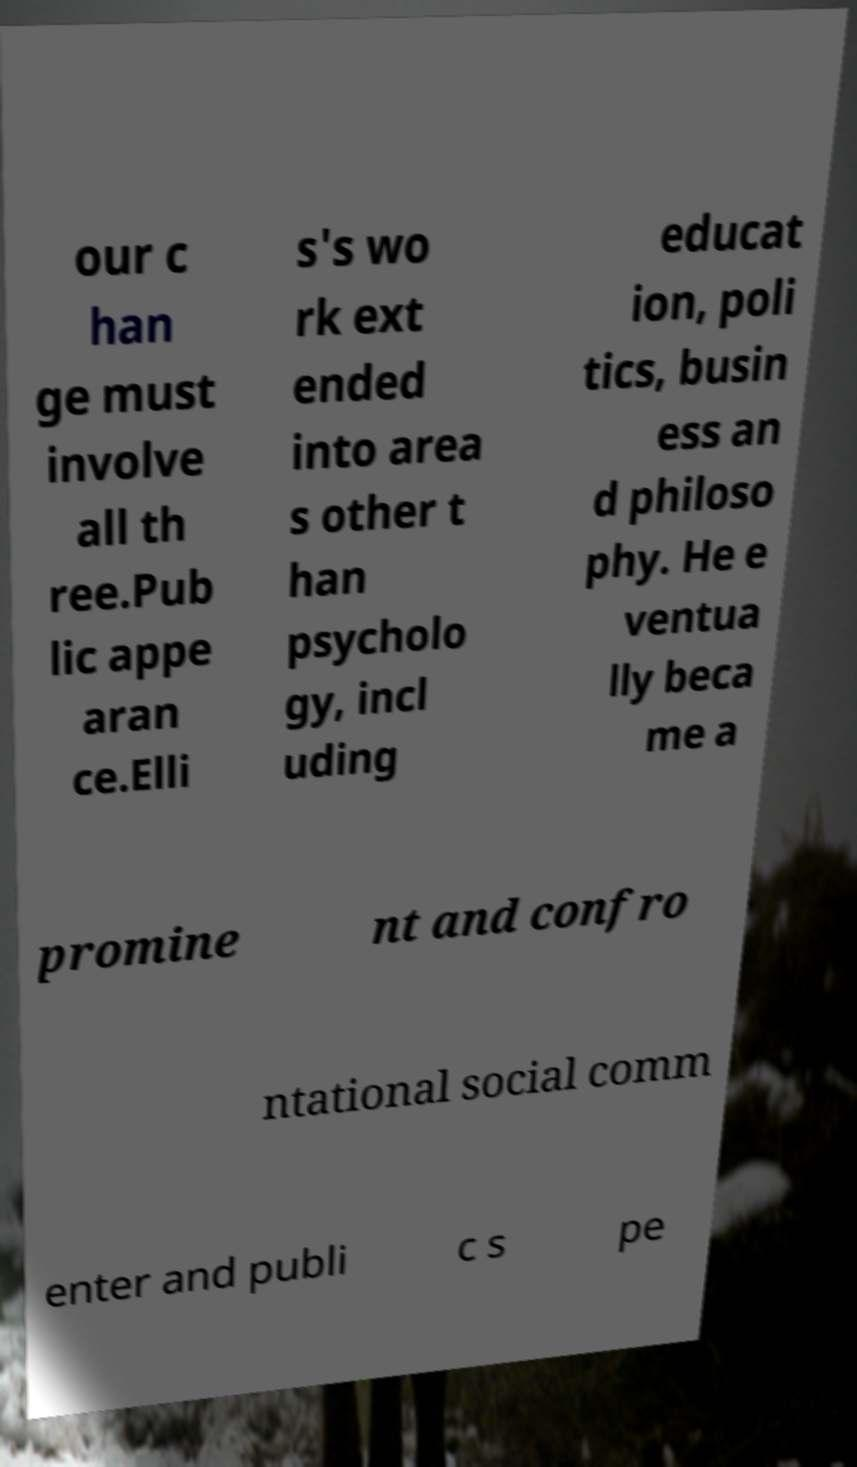Could you assist in decoding the text presented in this image and type it out clearly? our c han ge must involve all th ree.Pub lic appe aran ce.Elli s's wo rk ext ended into area s other t han psycholo gy, incl uding educat ion, poli tics, busin ess an d philoso phy. He e ventua lly beca me a promine nt and confro ntational social comm enter and publi c s pe 